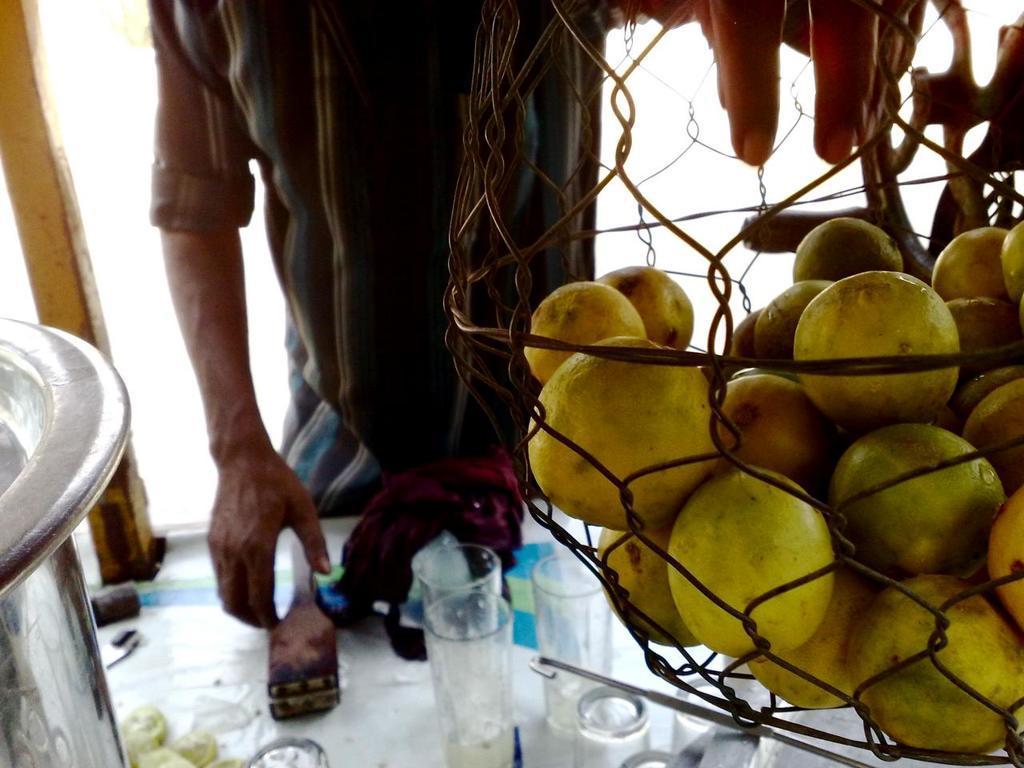How would you summarize this image in a sentence or two? In this image we can see lemons in the basket, there is a person, in front of the person there is a table, on the table there are few glasses and objects. 